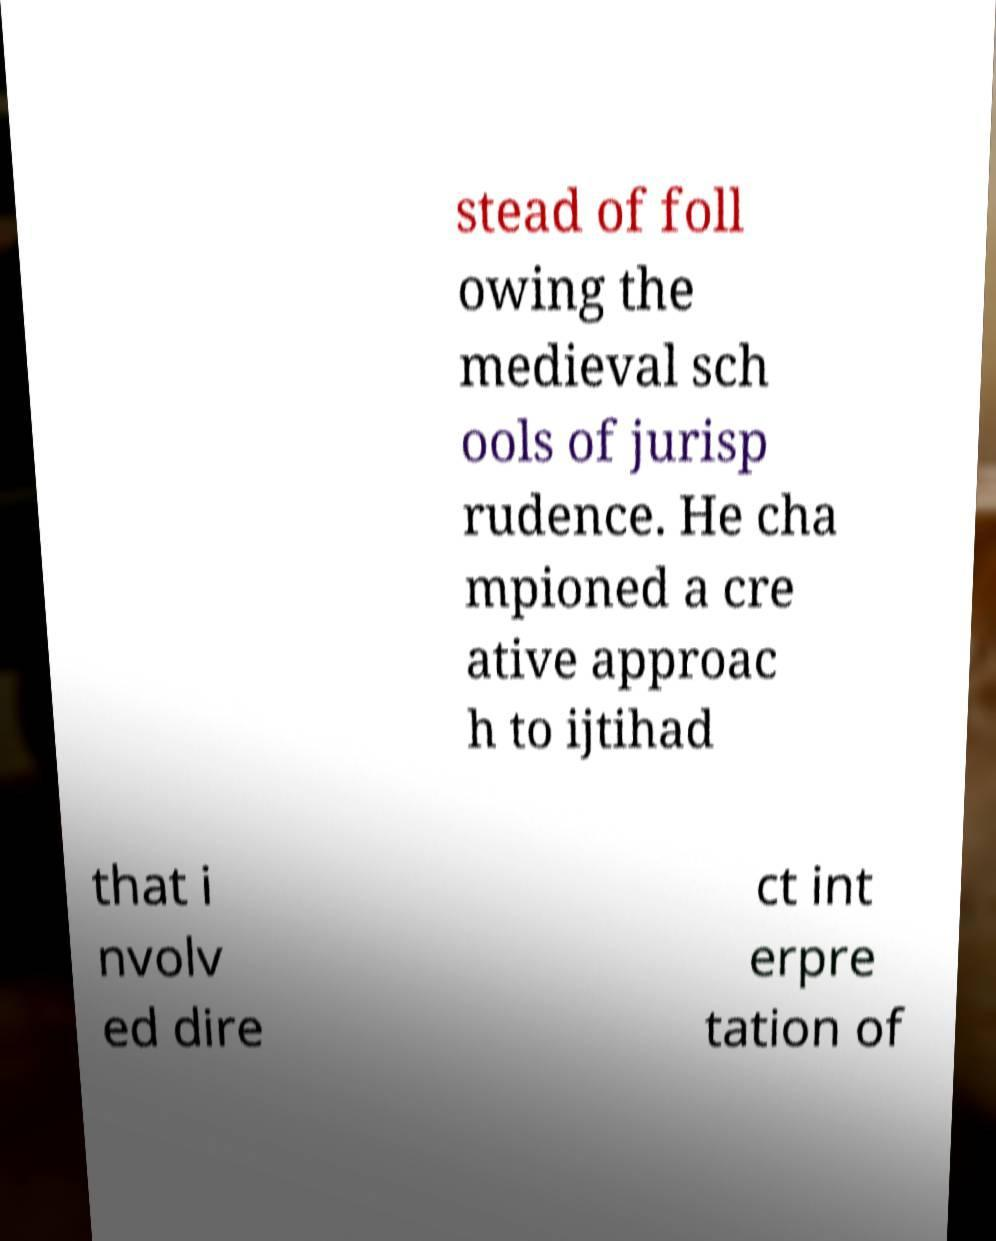Could you assist in decoding the text presented in this image and type it out clearly? stead of foll owing the medieval sch ools of jurisp rudence. He cha mpioned a cre ative approac h to ijtihad that i nvolv ed dire ct int erpre tation of 